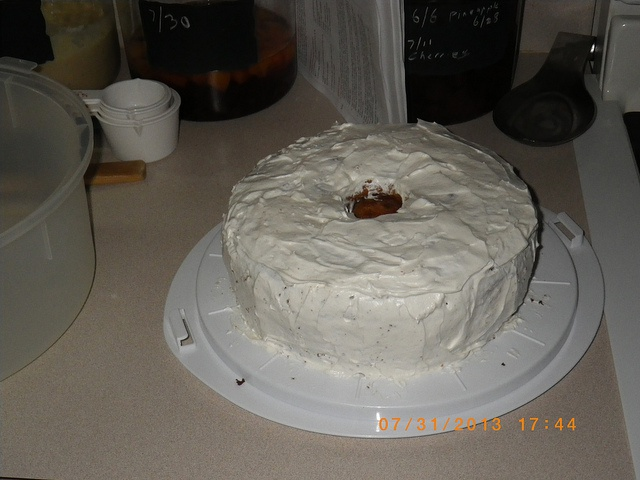Describe the objects in this image and their specific colors. I can see a cake in black, darkgray, and gray tones in this image. 